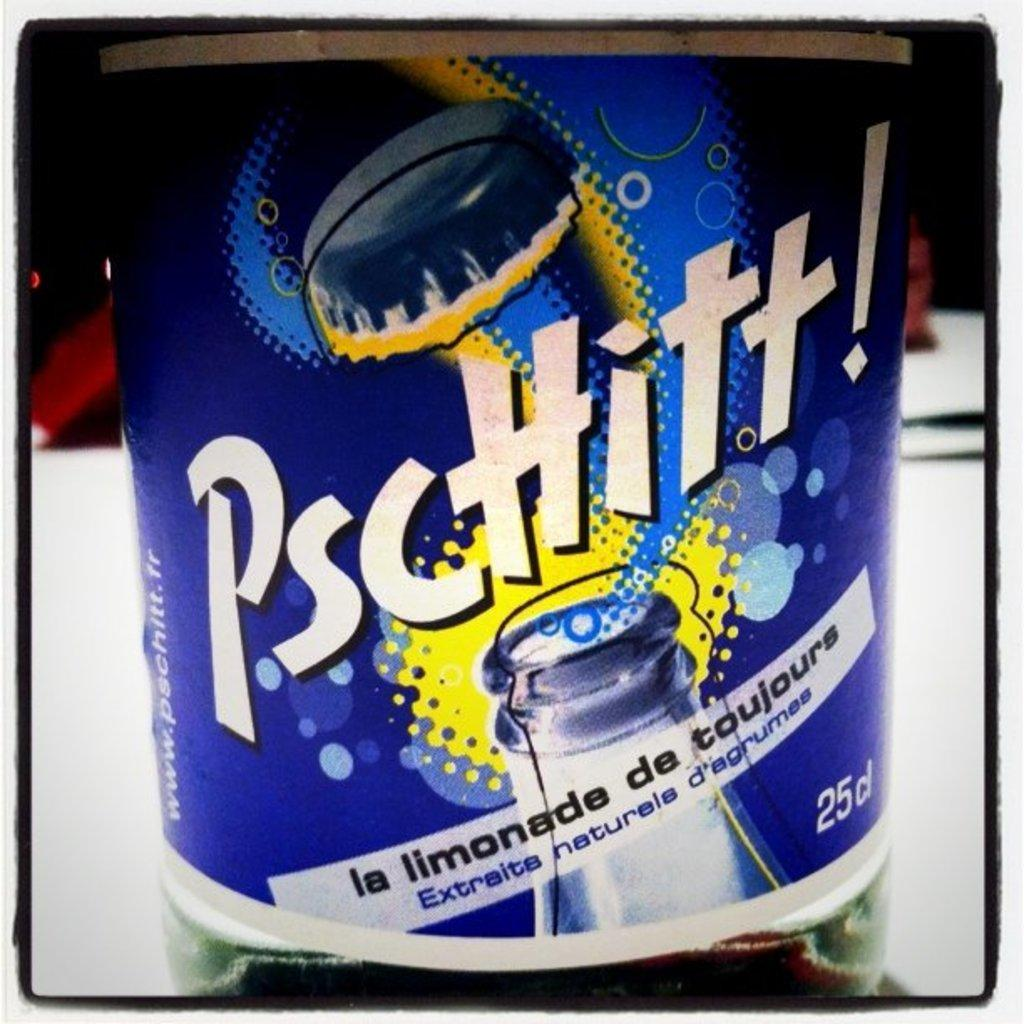<image>
Write a terse but informative summary of the picture. The label on a bottle of PscHitt, la limonada de toujours. 